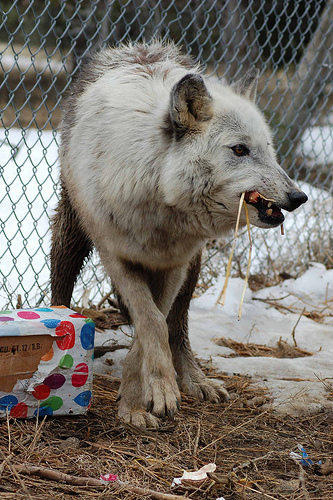<image>
Can you confirm if the fox is on the fence? No. The fox is not positioned on the fence. They may be near each other, but the fox is not supported by or resting on top of the fence. Is there a wolf to the right of the box? Yes. From this viewpoint, the wolf is positioned to the right side relative to the box. 